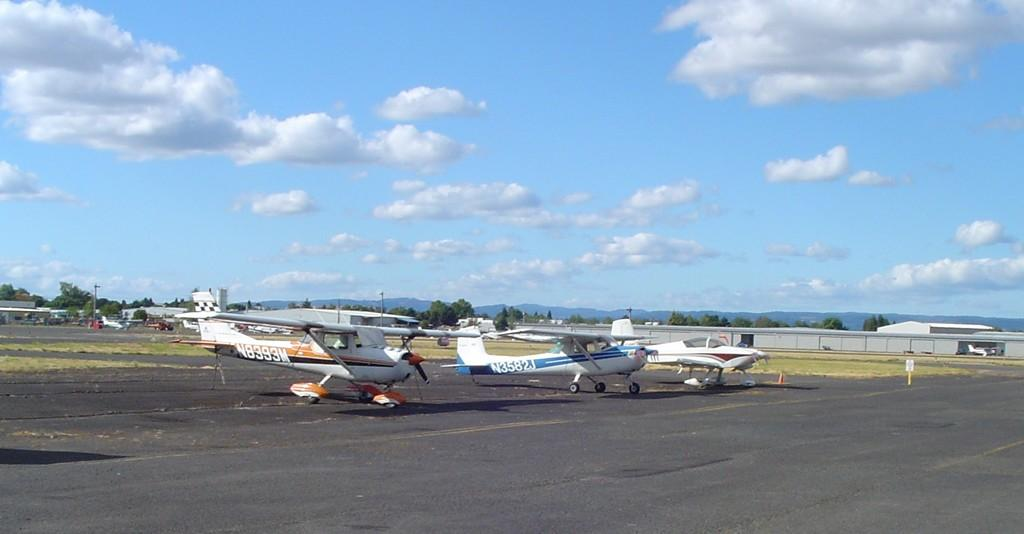<image>
Offer a succinct explanation of the picture presented. two airplanes marked N8393M andN3582J are sitting side by side 